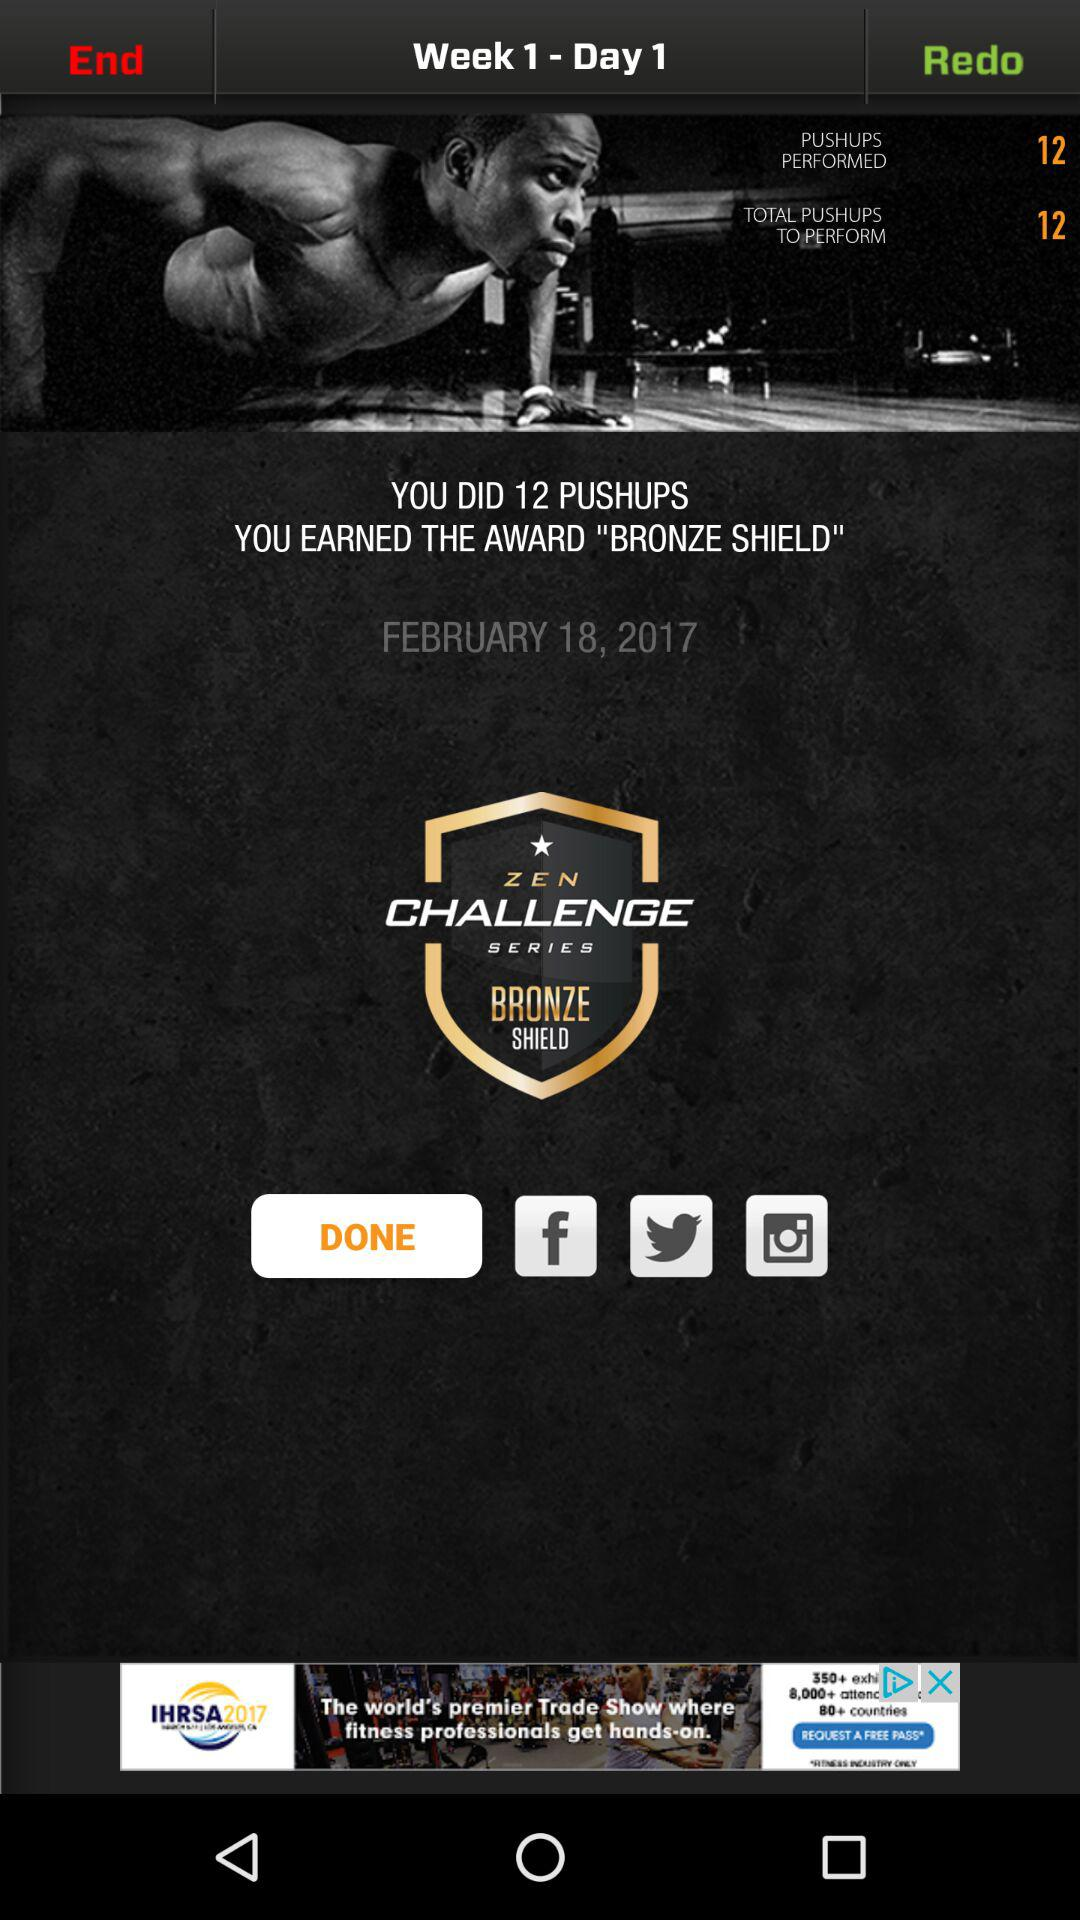How many pushups did you do? You did 12 pushups. 